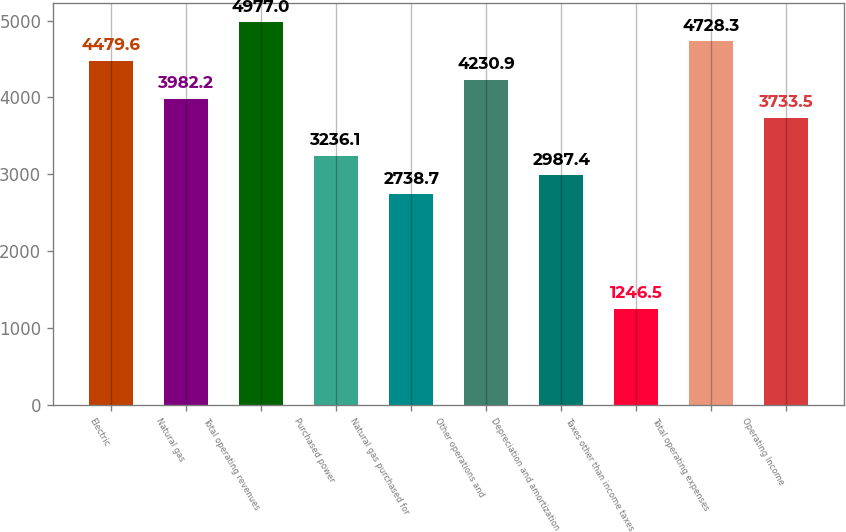Convert chart. <chart><loc_0><loc_0><loc_500><loc_500><bar_chart><fcel>Electric<fcel>Natural gas<fcel>Total operating revenues<fcel>Purchased power<fcel>Natural gas purchased for<fcel>Other operations and<fcel>Depreciation and amortization<fcel>Taxes other than income taxes<fcel>Total operating expenses<fcel>Operating Income<nl><fcel>4479.6<fcel>3982.2<fcel>4977<fcel>3236.1<fcel>2738.7<fcel>4230.9<fcel>2987.4<fcel>1246.5<fcel>4728.3<fcel>3733.5<nl></chart> 